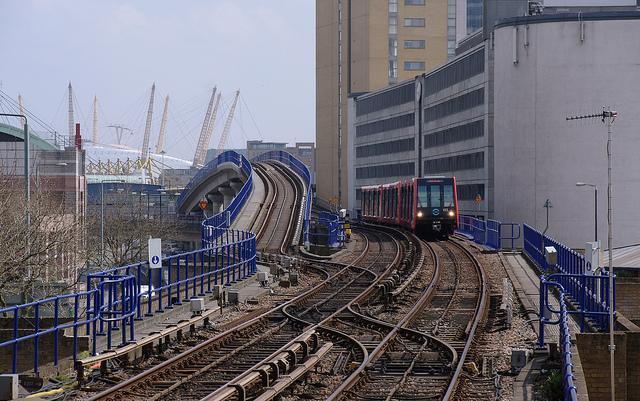How many train cars are on this train?
Give a very brief answer. 3. 